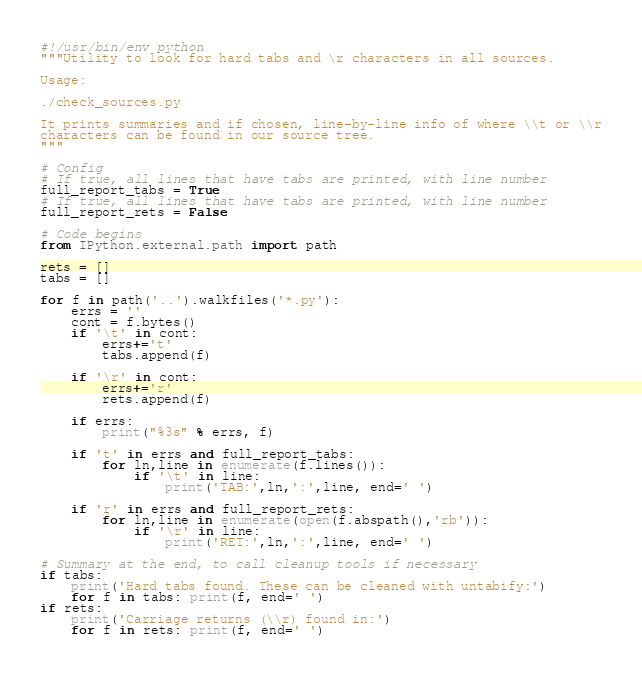<code> <loc_0><loc_0><loc_500><loc_500><_Python_>#!/usr/bin/env python
"""Utility to look for hard tabs and \r characters in all sources.

Usage:

./check_sources.py

It prints summaries and if chosen, line-by-line info of where \\t or \\r
characters can be found in our source tree.
"""

# Config
# If true, all lines that have tabs are printed, with line number
full_report_tabs = True
# If true, all lines that have tabs are printed, with line number
full_report_rets = False

# Code begins
from IPython.external.path import path

rets = []
tabs = []

for f in path('..').walkfiles('*.py'):
    errs = ''
    cont = f.bytes()
    if '\t' in cont:
        errs+='t'
        tabs.append(f)

    if '\r' in cont:
        errs+='r'
        rets.append(f)
        
    if errs:
        print("%3s" % errs, f)

    if 't' in errs and full_report_tabs:
        for ln,line in enumerate(f.lines()):
            if '\t' in line:
                print('TAB:',ln,':',line, end=' ')

    if 'r' in errs and full_report_rets:
        for ln,line in enumerate(open(f.abspath(),'rb')):
            if '\r' in line:
                print('RET:',ln,':',line, end=' ')

# Summary at the end, to call cleanup tools if necessary
if tabs:
    print('Hard tabs found. These can be cleaned with untabify:')
    for f in tabs: print(f, end=' ')
if rets:
    print('Carriage returns (\\r) found in:')
    for f in rets: print(f, end=' ')
</code> 